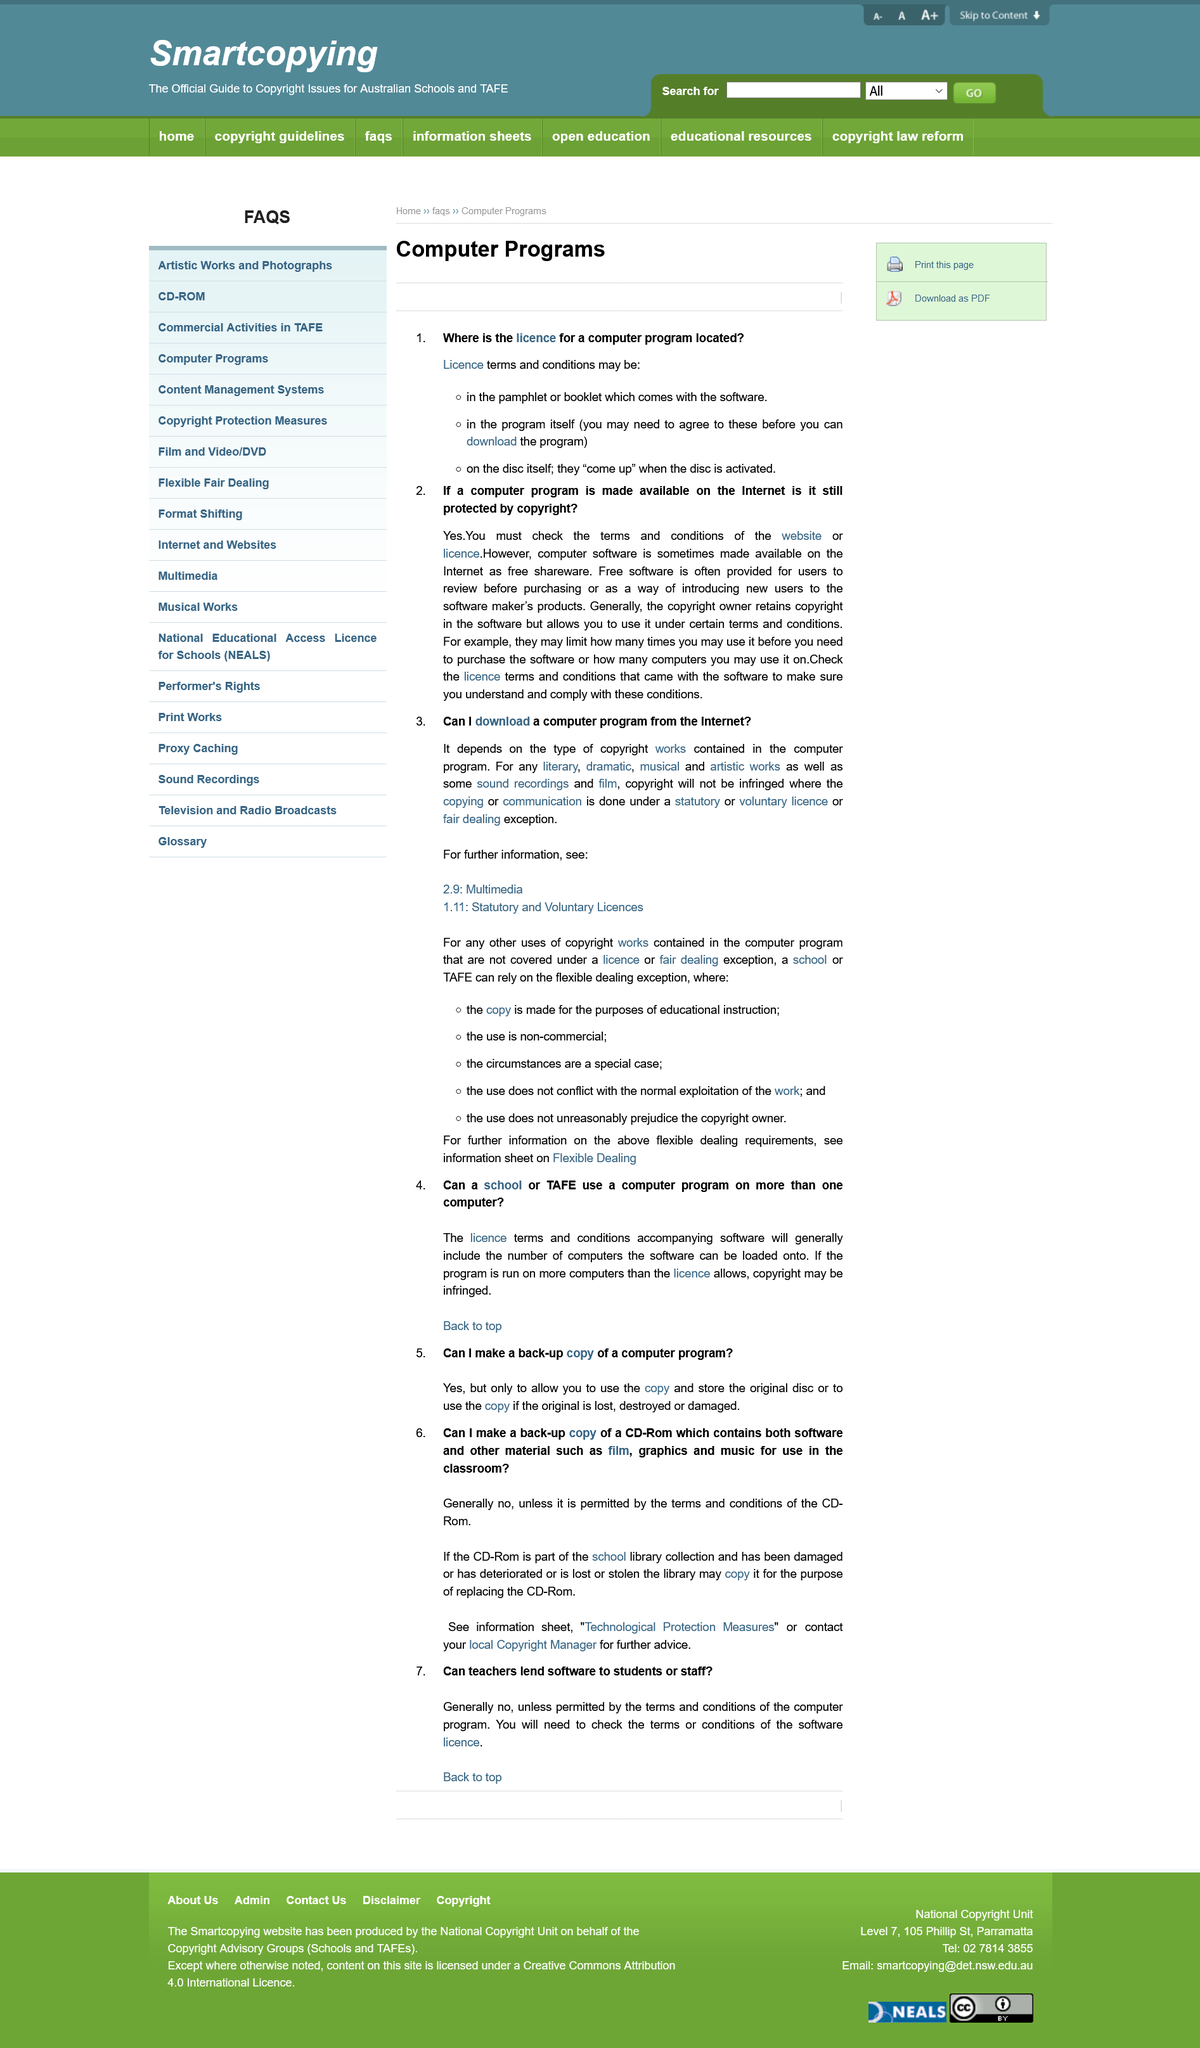Give some essential details in this illustration. If the program is run on more computers than the licence allows, copyright may be infringed. It is not permissible to make a backup copy of a CD-ROM for use in the classroom unless authorization is granted by the terms and conditions. It is possible to download a computer program from the internet, but it depends on the program's copyright type. It is not permissible for teachers to lend software to students unless the terms and conditions of the software specifically allow for such actions. Yes, a school may rely on the flexible dealing exception even if the use of a program is non-commercial. 